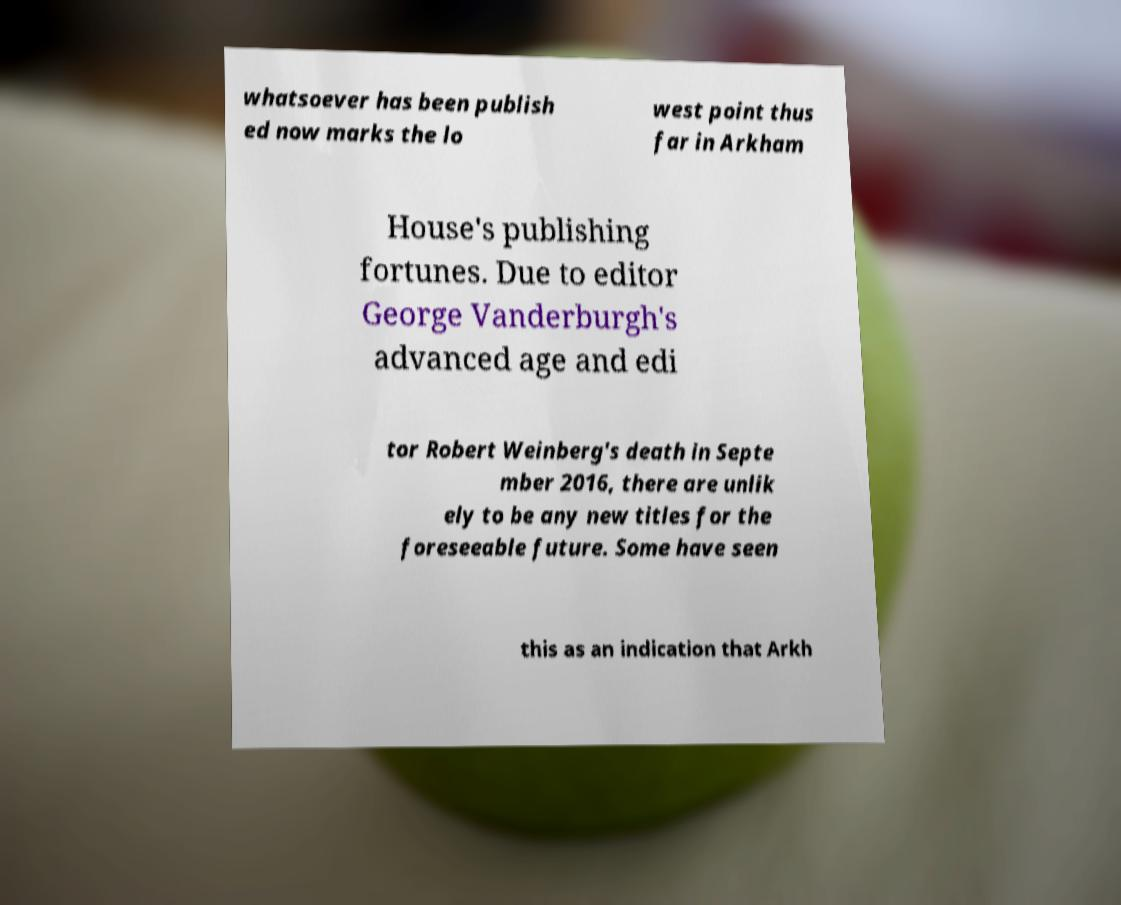Can you accurately transcribe the text from the provided image for me? whatsoever has been publish ed now marks the lo west point thus far in Arkham House's publishing fortunes. Due to editor George Vanderburgh's advanced age and edi tor Robert Weinberg's death in Septe mber 2016, there are unlik ely to be any new titles for the foreseeable future. Some have seen this as an indication that Arkh 